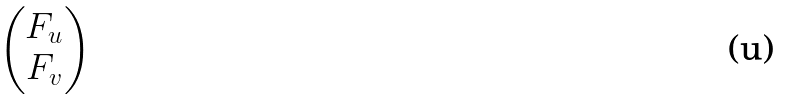<formula> <loc_0><loc_0><loc_500><loc_500>\begin{pmatrix} F _ { u } \\ F _ { v } \end{pmatrix}</formula> 